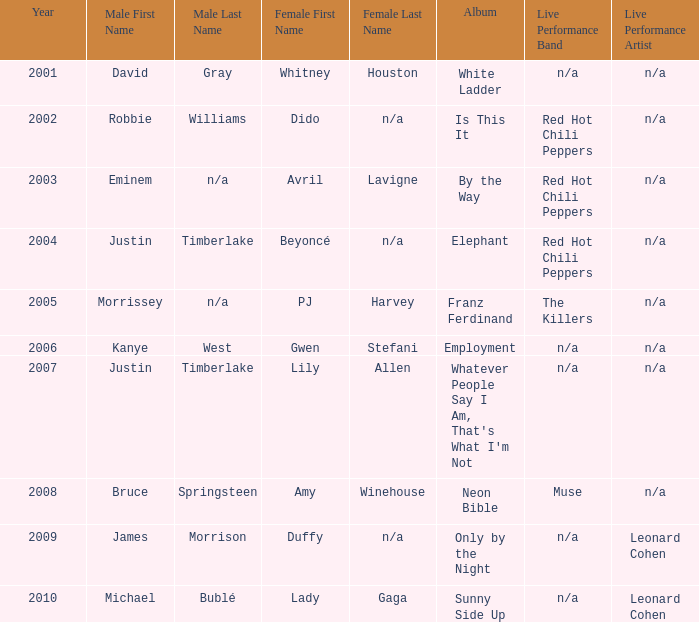Which male is paired with dido in 2004? Robbie Williams. 